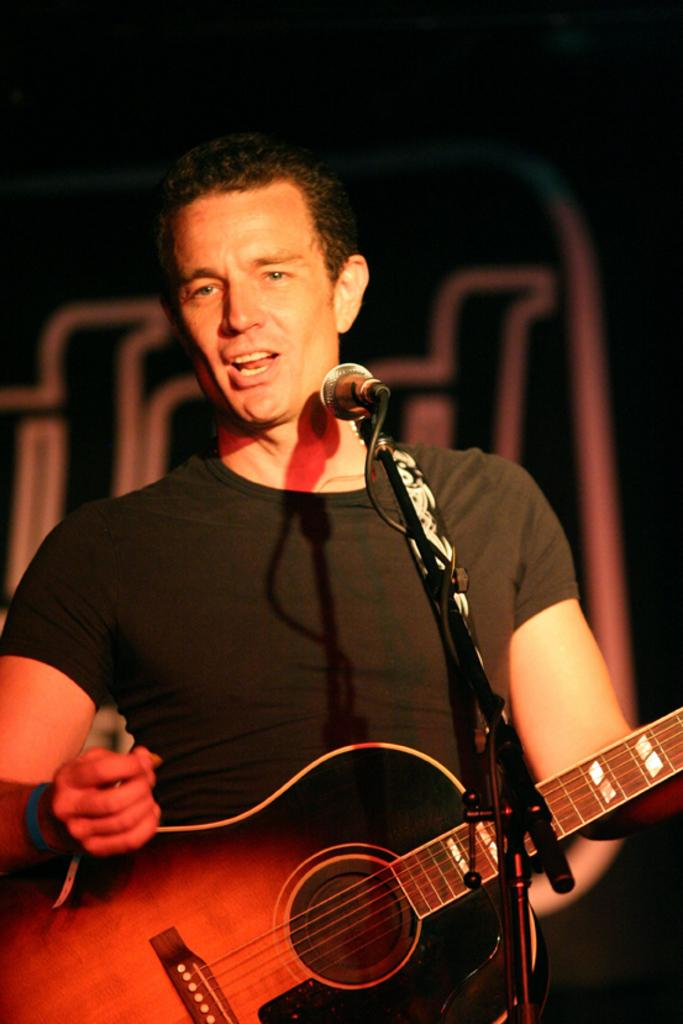Who is the main subject in the image? There is a man in the image. What is the man wearing? The man is wearing a black t-shirt. What is the man doing in the image? The man is standing and singing. What object is the man holding? The man is holding a guitar. What is in front of the man? There is a microphone in front of the man. What type of trousers is the actor wearing in the image? There is no actor present in the image, and the man's trousers are not mentioned in the facts. 